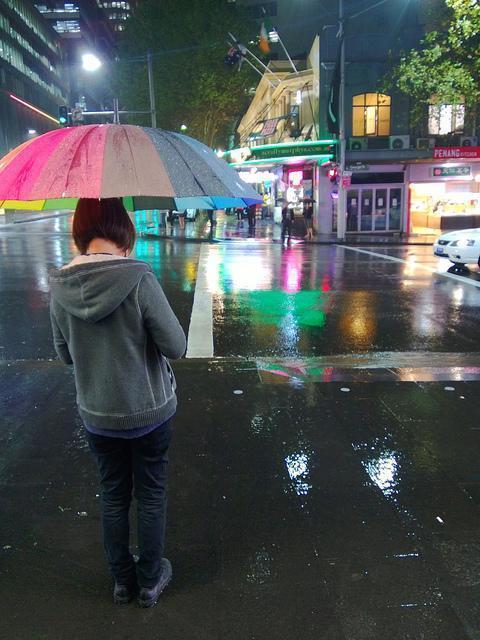What does the person standing here wait to see?
Make your selection from the four choices given to correctly answer the question.
Options: Walk light, candle, their friend, warning. Walk light. 